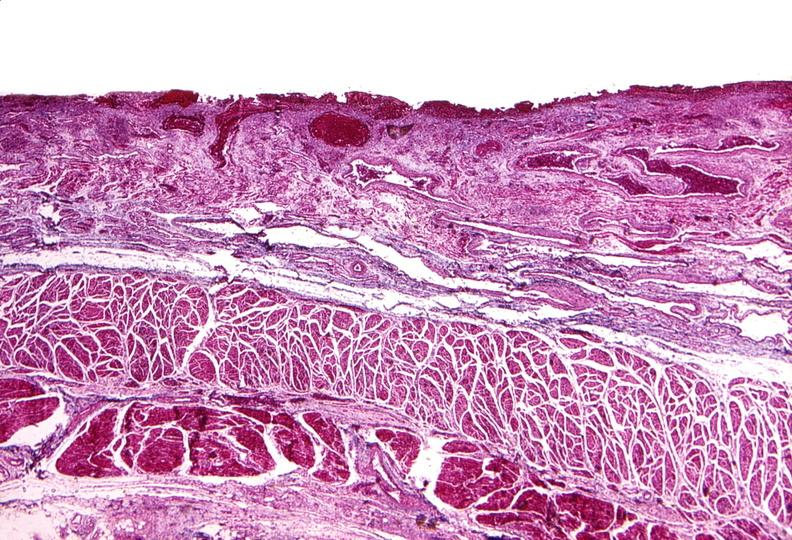where is this from?
Answer the question using a single word or phrase. Gastrointestinal system 